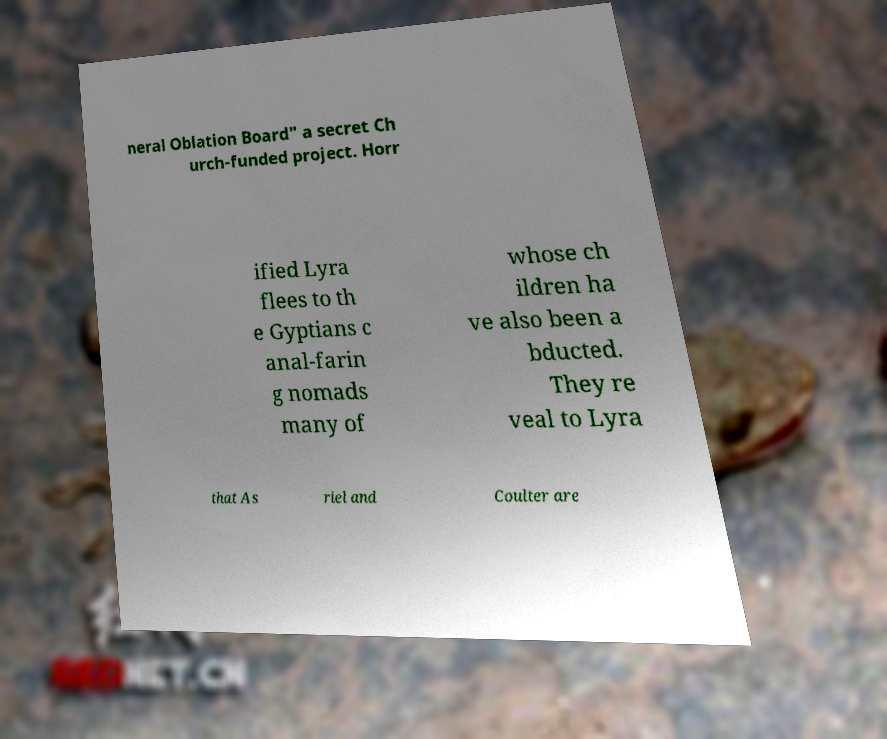Can you accurately transcribe the text from the provided image for me? neral Oblation Board" a secret Ch urch-funded project. Horr ified Lyra flees to th e Gyptians c anal-farin g nomads many of whose ch ildren ha ve also been a bducted. They re veal to Lyra that As riel and Coulter are 